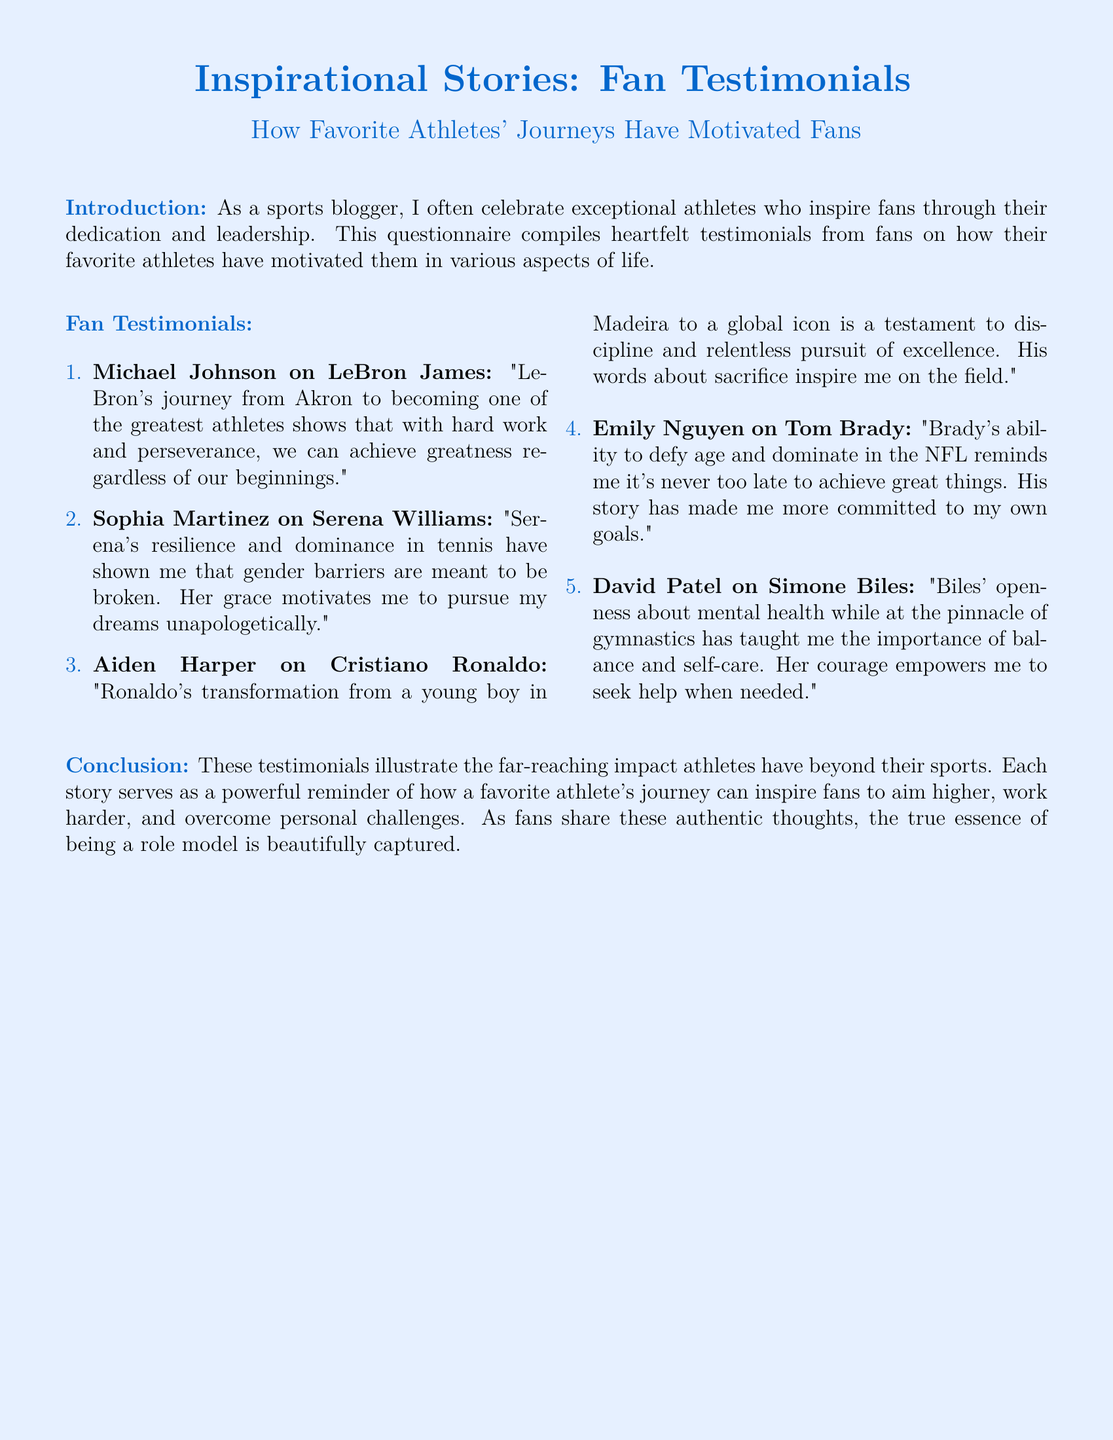What is the main theme of the document? The main theme of the document is the impact of favorite athletes on their fans' lives through inspiration and motivation.
Answer: Inspirational impact How many fan testimonials are included in the document? The total number of fan testimonials listed under "Fan Testimonials" is five.
Answer: Five Who is inspired by LeBron James according to the document? The document mentions Michael Johnson as the one inspired by LeBron James.
Answer: Michael Johnson What aspect of Simone Biles' story is highlighted in her testimonial? The testimonial emphasizes her openness about mental health and self-care.
Answer: Mental health Which athlete is mentioned as a role model for breaking gender barriers? The athlete referenced for breaking gender barriers is Serena Williams.
Answer: Serena Williams What does Emily Nguyen say about age and achievement? Emily Nguyen states that Brady's story has shown her it's never too late to achieve great things.
Answer: It's never too late Who expresses admiration for Cristiano Ronaldo's discipline? Aiden Harper expresses admiration for Cristiano Ronaldo's discipline and pursuit of excellence.
Answer: Aiden Harper What motivating factor does David Patel associate with Simone Biles? David Patel associates Biles' courage with seeking help when needed.
Answer: Courage to seek help 